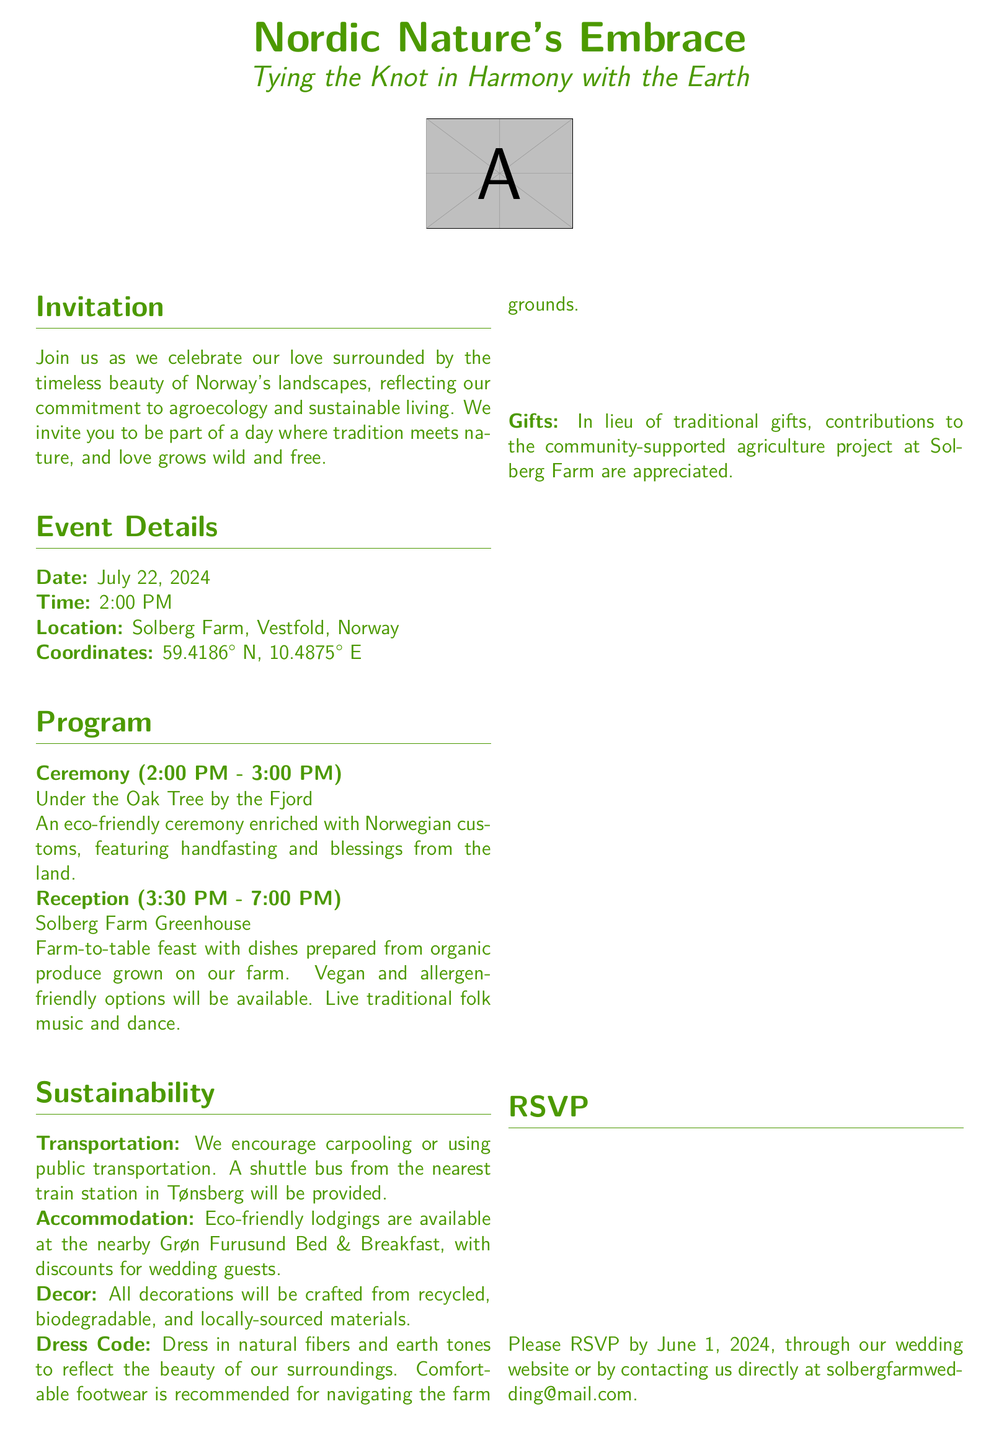What is the wedding date? The wedding date is explicitly stated in the document as July 22, 2024.
Answer: July 22, 2024 Where will the reception take place? The reception location is provided in the document as Solberg Farm Greenhouse.
Answer: Solberg Farm Greenhouse What time does the ceremony start? The document clearly indicates that the ceremony starts at 2:00 PM.
Answer: 2:00 PM What type of music will be performed at the reception? The document mentions live traditional folk music will be part of the reception.
Answer: Traditional folk music What should guests wear? The dress code specified in the document asks guests to wear natural fibers and earth tones.
Answer: Natural fibers and earth tones What kind of transport is encouraged? The document suggests carpooling or using public transportation for getting to the venue.
Answer: Carpooling What should guests bring instead of traditional gifts? The document states that contributions to the community-supported agriculture project are appreciated instead of traditional gifts.
Answer: Contributions to the community-supported agriculture project What is the RSVP deadline? The document sets the RSVP deadline to June 1, 2024.
Answer: June 1, 2024 What is the purpose of the ceremony under the Oak Tree? The document describes it as an eco-friendly ceremony enriched with Norwegian customs and blessings from the land.
Answer: Eco-friendly ceremony enriched with Norwegian customs 